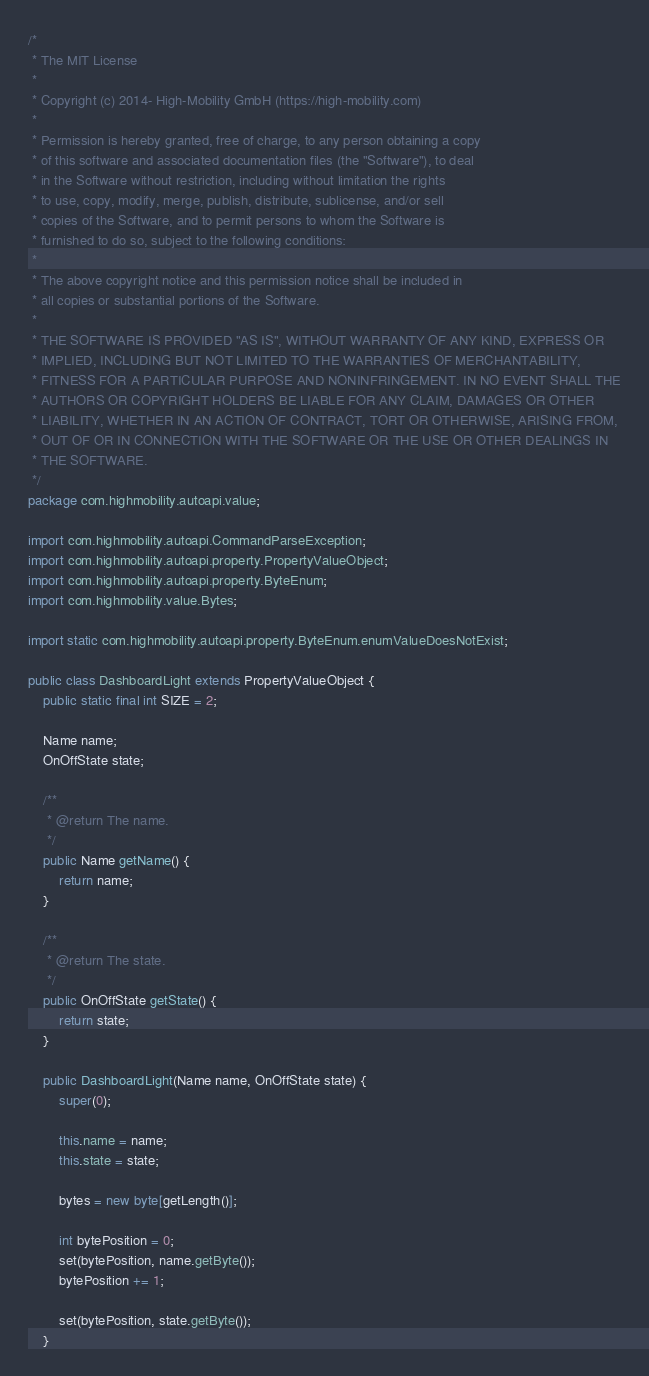Convert code to text. <code><loc_0><loc_0><loc_500><loc_500><_Java_>/*
 * The MIT License
 * 
 * Copyright (c) 2014- High-Mobility GmbH (https://high-mobility.com)
 * 
 * Permission is hereby granted, free of charge, to any person obtaining a copy
 * of this software and associated documentation files (the "Software"), to deal
 * in the Software without restriction, including without limitation the rights
 * to use, copy, modify, merge, publish, distribute, sublicense, and/or sell
 * copies of the Software, and to permit persons to whom the Software is
 * furnished to do so, subject to the following conditions:
 * 
 * The above copyright notice and this permission notice shall be included in
 * all copies or substantial portions of the Software.
 * 
 * THE SOFTWARE IS PROVIDED "AS IS", WITHOUT WARRANTY OF ANY KIND, EXPRESS OR
 * IMPLIED, INCLUDING BUT NOT LIMITED TO THE WARRANTIES OF MERCHANTABILITY,
 * FITNESS FOR A PARTICULAR PURPOSE AND NONINFRINGEMENT. IN NO EVENT SHALL THE
 * AUTHORS OR COPYRIGHT HOLDERS BE LIABLE FOR ANY CLAIM, DAMAGES OR OTHER
 * LIABILITY, WHETHER IN AN ACTION OF CONTRACT, TORT OR OTHERWISE, ARISING FROM,
 * OUT OF OR IN CONNECTION WITH THE SOFTWARE OR THE USE OR OTHER DEALINGS IN
 * THE SOFTWARE.
 */
package com.highmobility.autoapi.value;

import com.highmobility.autoapi.CommandParseException;
import com.highmobility.autoapi.property.PropertyValueObject;
import com.highmobility.autoapi.property.ByteEnum;
import com.highmobility.value.Bytes;

import static com.highmobility.autoapi.property.ByteEnum.enumValueDoesNotExist;

public class DashboardLight extends PropertyValueObject {
    public static final int SIZE = 2;

    Name name;
    OnOffState state;

    /**
     * @return The name.
     */
    public Name getName() {
        return name;
    }

    /**
     * @return The state.
     */
    public OnOffState getState() {
        return state;
    }

    public DashboardLight(Name name, OnOffState state) {
        super(0);

        this.name = name;
        this.state = state;

        bytes = new byte[getLength()];

        int bytePosition = 0;
        set(bytePosition, name.getByte());
        bytePosition += 1;

        set(bytePosition, state.getByte());
    }
</code> 